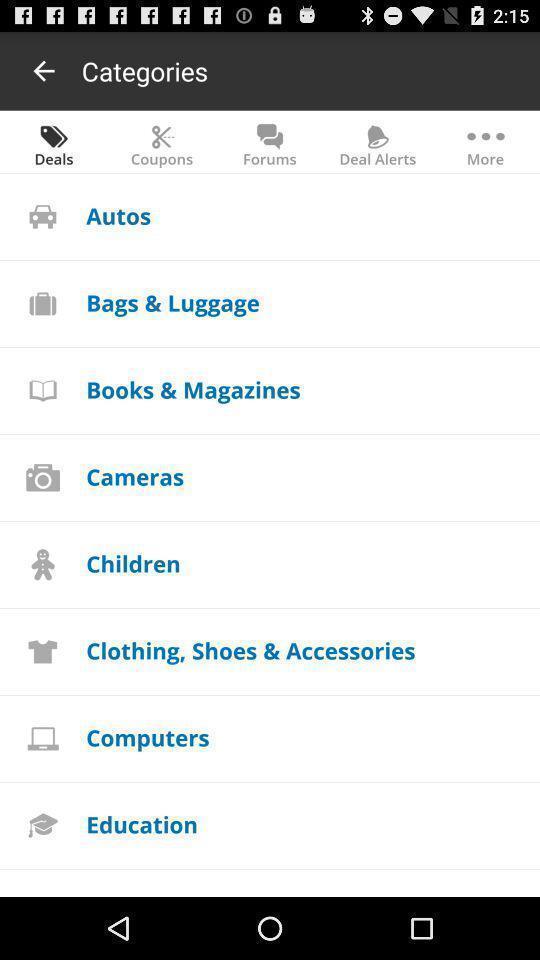Give me a summary of this screen capture. Shopping page displayed different categories and other options. 